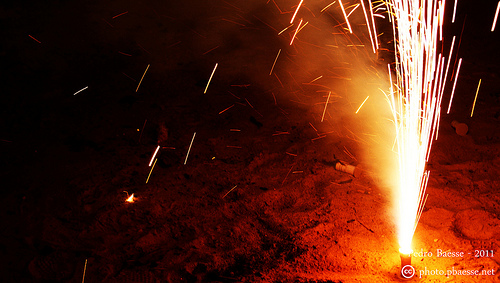<image>
Can you confirm if the sparks is above the sand? Yes. The sparks is positioned above the sand in the vertical space, higher up in the scene. 